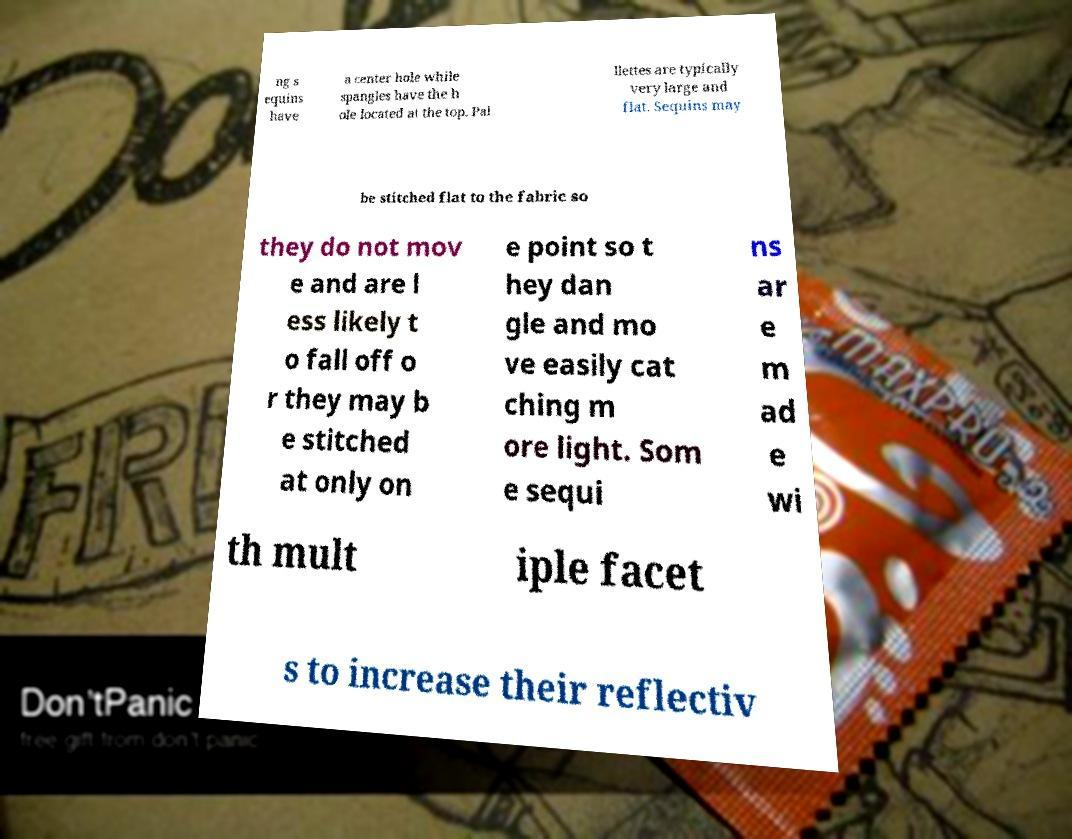Could you assist in decoding the text presented in this image and type it out clearly? ng s equins have a center hole while spangles have the h ole located at the top. Pai llettes are typically very large and flat. Sequins may be stitched flat to the fabric so they do not mov e and are l ess likely t o fall off o r they may b e stitched at only on e point so t hey dan gle and mo ve easily cat ching m ore light. Som e sequi ns ar e m ad e wi th mult iple facet s to increase their reflectiv 